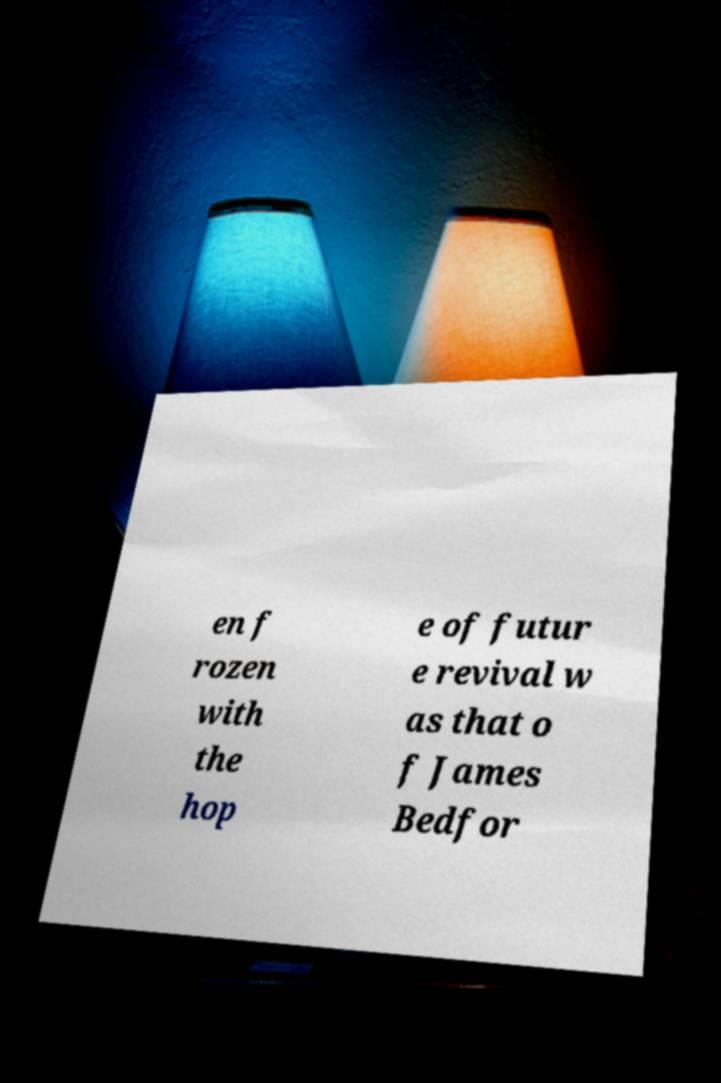Please identify and transcribe the text found in this image. en f rozen with the hop e of futur e revival w as that o f James Bedfor 